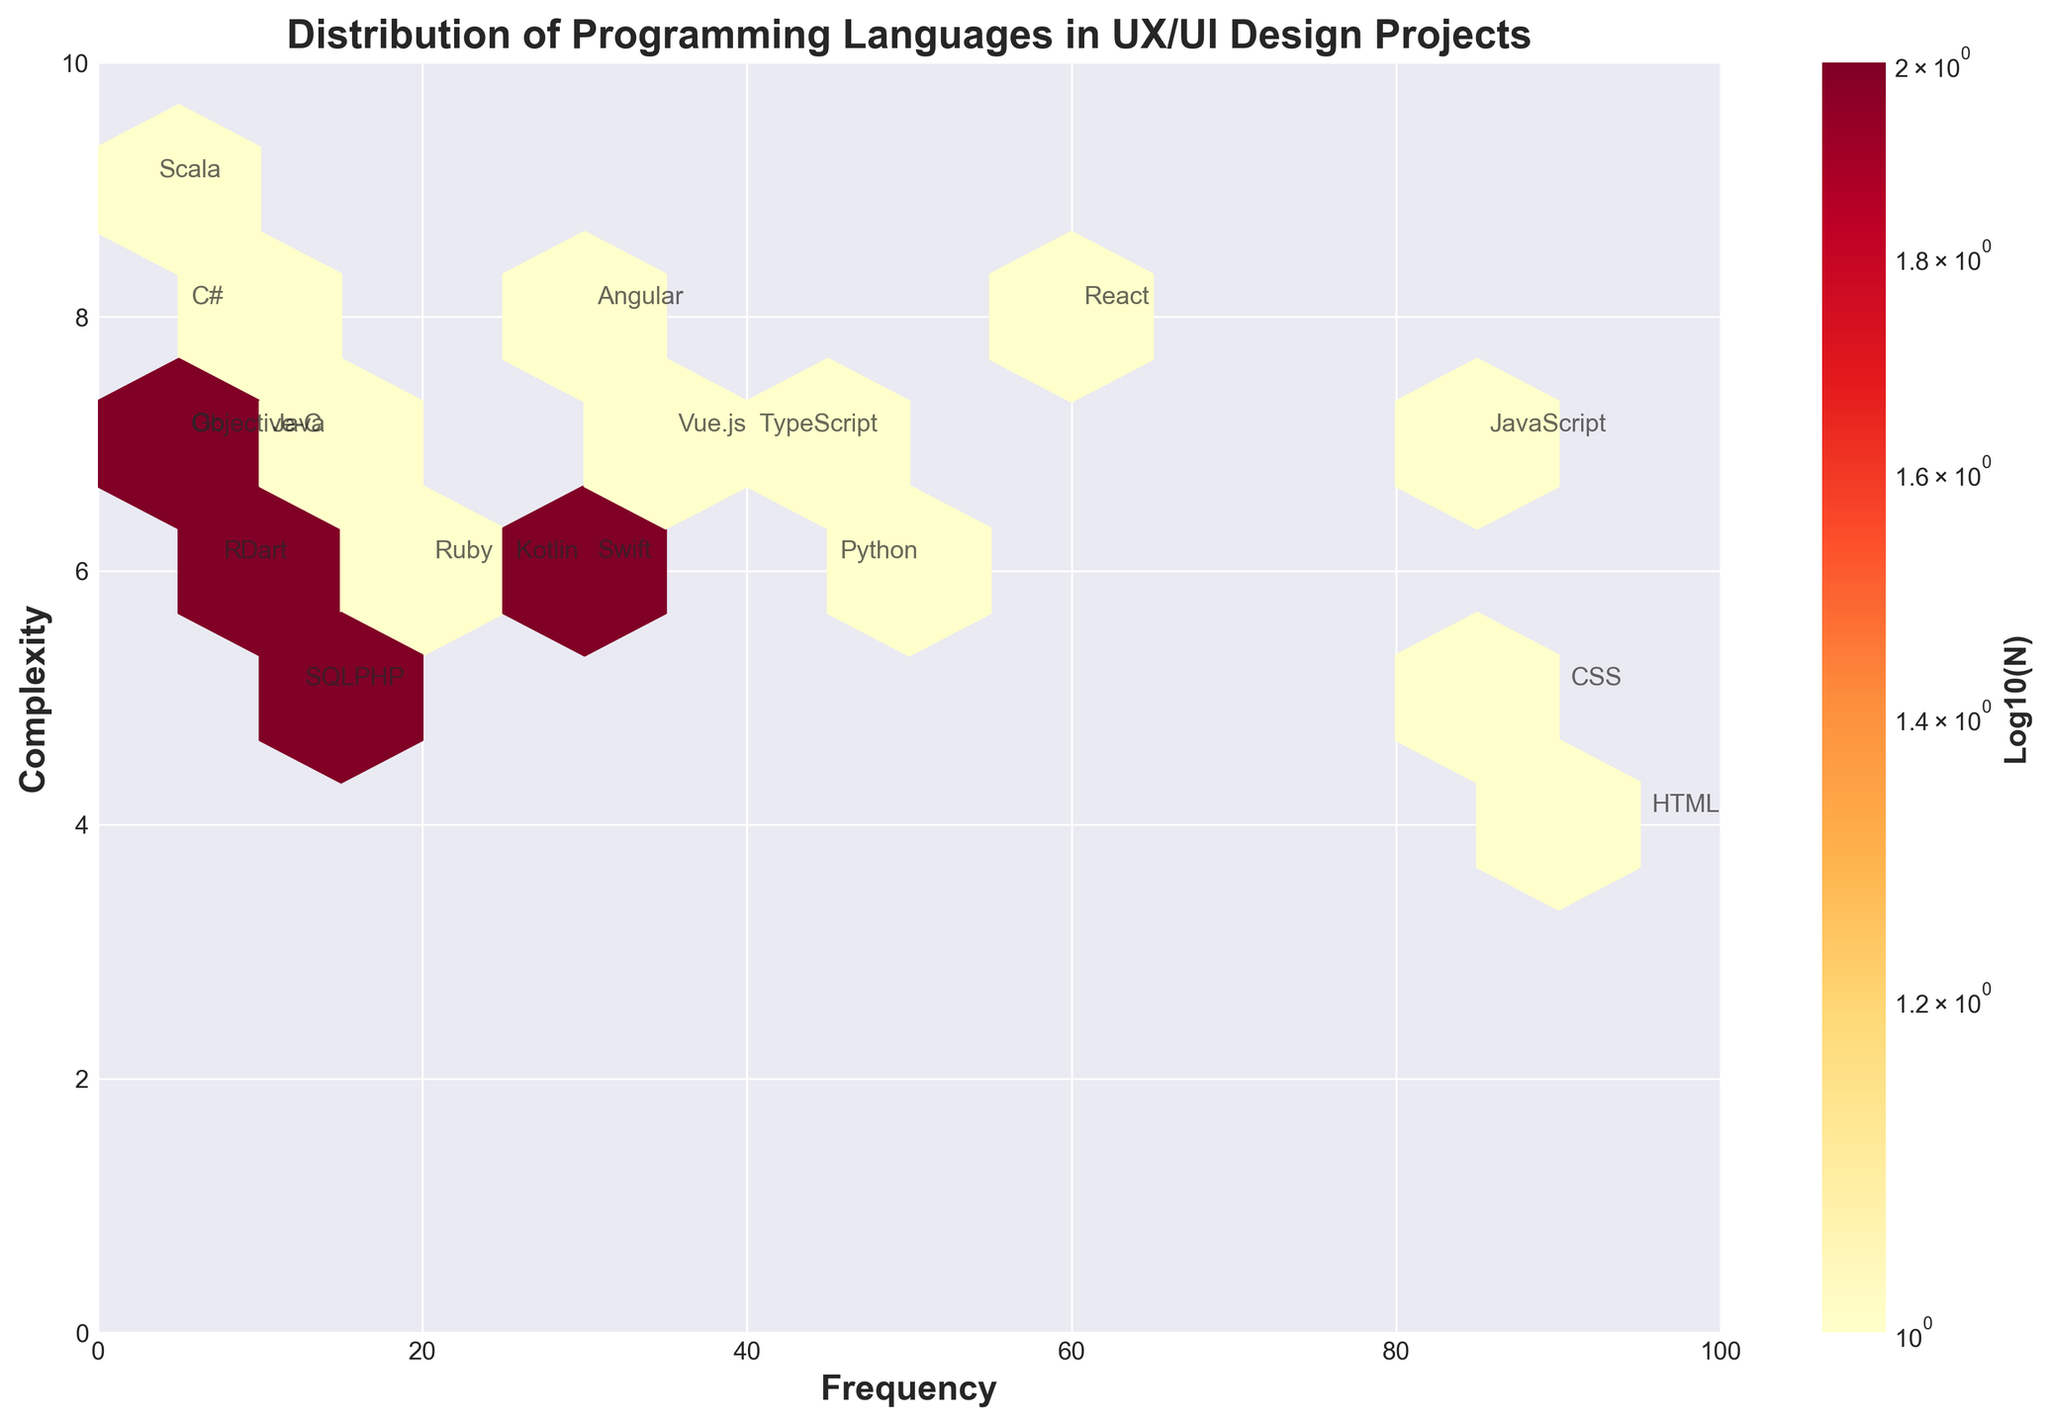What's the title of the figure? The title is always present at the top of the figure in a larger and bolder font compared to other text elements. This helps viewers quickly understand what the plot is about.
Answer: Distribution of Programming Languages in UX/UI Design Projects What do the colors indicate? Colors in a hexbin plot usually represent the density or frequency of data points within each hexagon. Darker colors imply higher density while lighter colors imply lower density. This visual cue helps in identifying concentration areas.
Answer: Different densities of programming languages How many programming languages have a complexity level of 6? To answer this, look at the y-axis labeled 'Complexity', find the value 6, and then count how many points are annotated with language names at this complexity level.
Answer: 6 Which programming language is most frequently used and at what complexity level? By looking at the x-axis labeled 'Frequency', locate the highest value, which indicates the most frequent language, and find the corresponding point on the y-axis to note down its complexity level.
Answer: HTML, complexity 4 Which language has the lowest frequency and what is its complexity level? Identifying the lowest point on the x-axis indicates the least frequent language, and then finding its y-axis value will give its complexity level.
Answer: Scala, complexity 9 Which programming languages have a frequency between 30 and 40? By locating the range between 30 and 40 on the x-axis, identify the languages listed within this range. This requires cross-referencing both axes.
Answer: Swift, Kotlin, Vue.js Which two languages have the highest complexity level and what are their frequencies? Locate the highest values on the y-axis for complexity and then identify the corresponding x-axis values for frequency.
Answer: Scala and C#, frequencies 3 and 5 How is the complexity of React compared to Vue.js? Identify the positions of both React and Vue.js on the y-axis to compare their complexity values directly.
Answer: Higher What's the total frequency of languages with a complexity level of 5? Sum the frequencies of all languages that have a complexity level of 5 by identifying their positions on the y-axis and adding up their corresponding x-axis values.
Answer: 115 